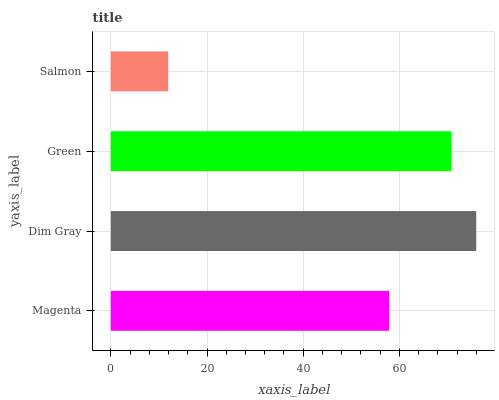Is Salmon the minimum?
Answer yes or no. Yes. Is Dim Gray the maximum?
Answer yes or no. Yes. Is Green the minimum?
Answer yes or no. No. Is Green the maximum?
Answer yes or no. No. Is Dim Gray greater than Green?
Answer yes or no. Yes. Is Green less than Dim Gray?
Answer yes or no. Yes. Is Green greater than Dim Gray?
Answer yes or no. No. Is Dim Gray less than Green?
Answer yes or no. No. Is Green the high median?
Answer yes or no. Yes. Is Magenta the low median?
Answer yes or no. Yes. Is Salmon the high median?
Answer yes or no. No. Is Dim Gray the low median?
Answer yes or no. No. 